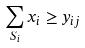<formula> <loc_0><loc_0><loc_500><loc_500>\sum _ { S _ { i } } x _ { i } \geq y _ { i j }</formula> 